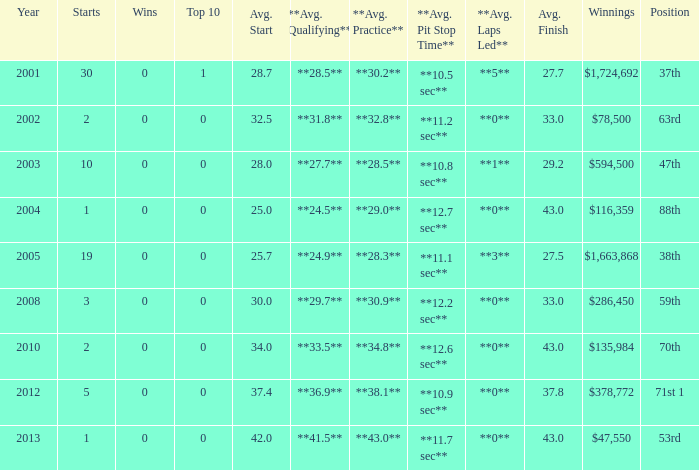What is the average top 10 score for 2 starts, winnings of $135,984 and an average finish more than 43? None. 